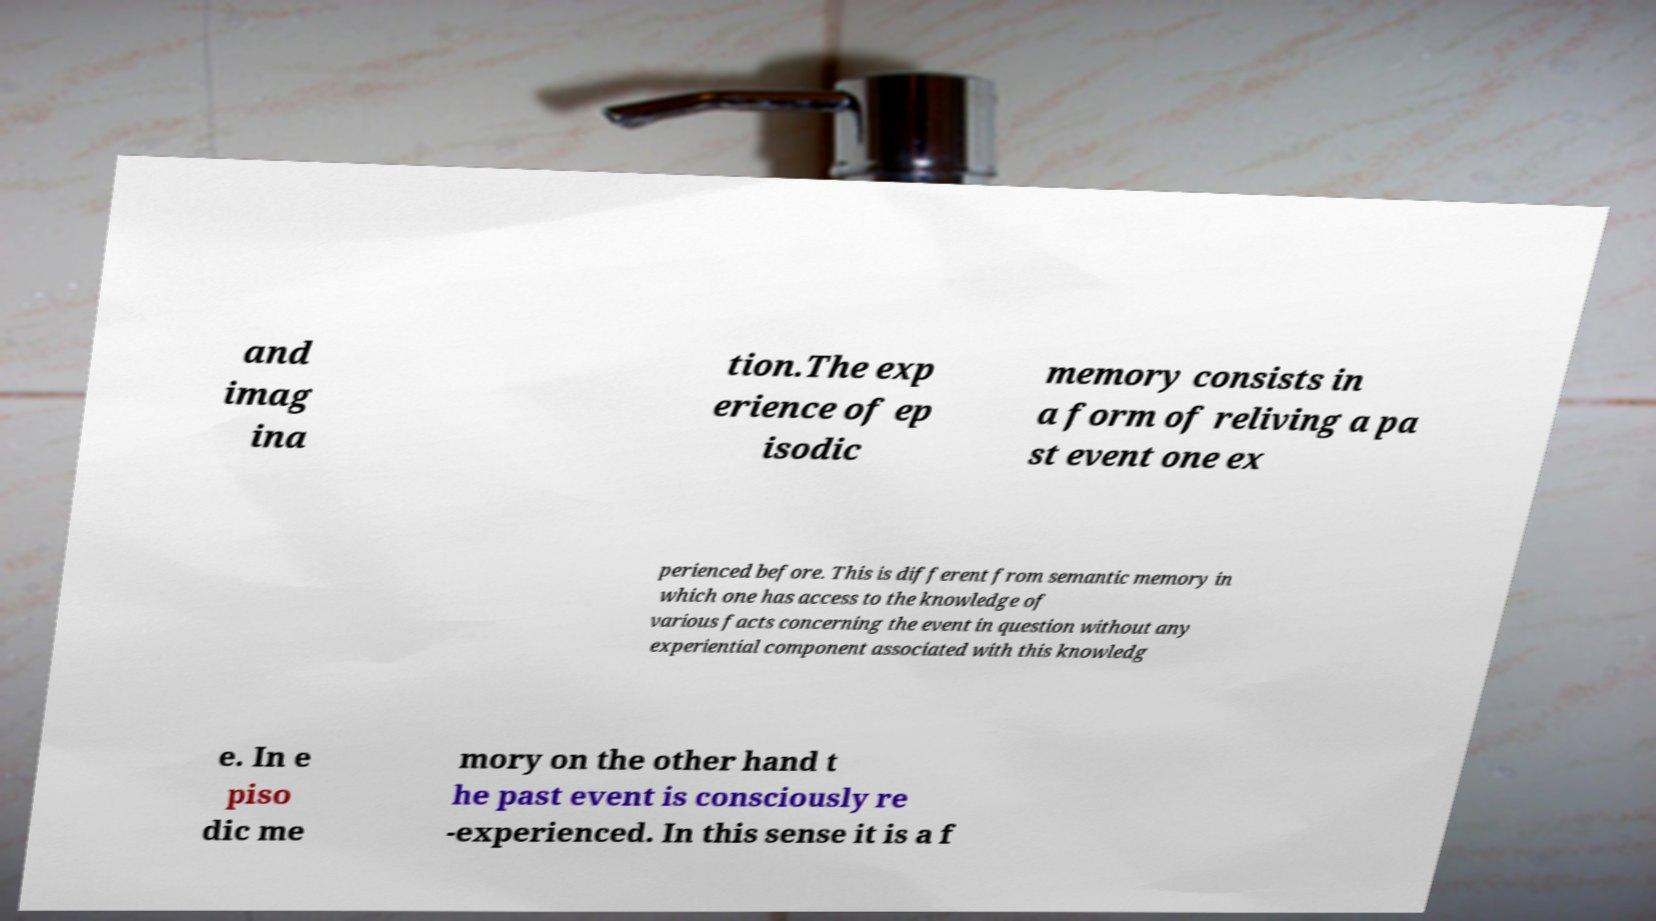Please read and relay the text visible in this image. What does it say? and imag ina tion.The exp erience of ep isodic memory consists in a form of reliving a pa st event one ex perienced before. This is different from semantic memory in which one has access to the knowledge of various facts concerning the event in question without any experiential component associated with this knowledg e. In e piso dic me mory on the other hand t he past event is consciously re -experienced. In this sense it is a f 